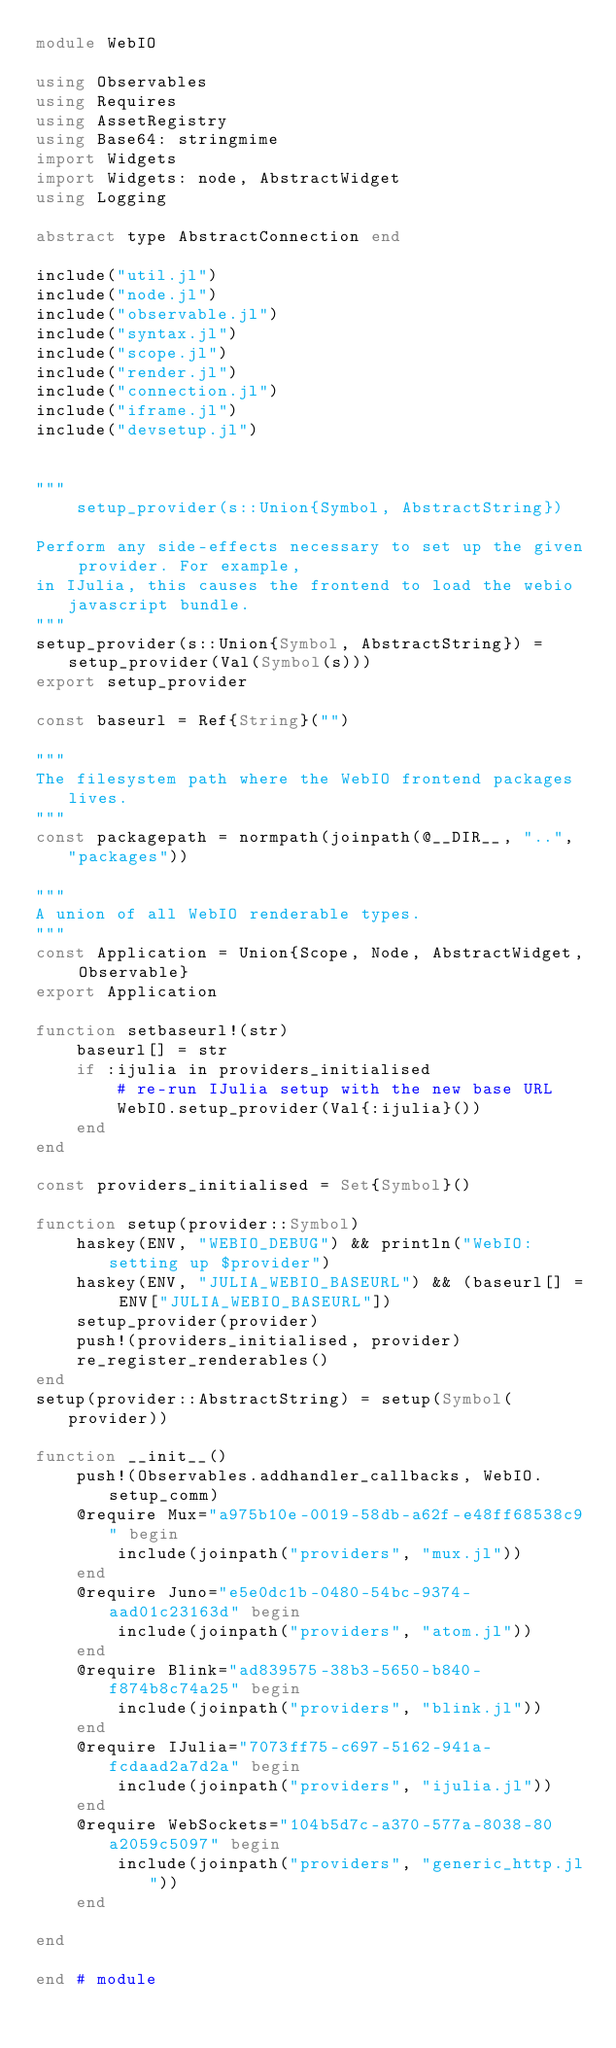Convert code to text. <code><loc_0><loc_0><loc_500><loc_500><_Julia_>module WebIO

using Observables
using Requires
using AssetRegistry
using Base64: stringmime
import Widgets
import Widgets: node, AbstractWidget
using Logging

abstract type AbstractConnection end

include("util.jl")
include("node.jl")
include("observable.jl")
include("syntax.jl")
include("scope.jl")
include("render.jl")
include("connection.jl")
include("iframe.jl")
include("devsetup.jl")


"""
    setup_provider(s::Union{Symbol, AbstractString})

Perform any side-effects necessary to set up the given provider. For example,
in IJulia, this causes the frontend to load the webio javascript bundle.
"""
setup_provider(s::Union{Symbol, AbstractString}) = setup_provider(Val(Symbol(s)))
export setup_provider

const baseurl = Ref{String}("")

"""
The filesystem path where the WebIO frontend packages lives.
"""
const packagepath = normpath(joinpath(@__DIR__, "..", "packages"))

"""
A union of all WebIO renderable types.
"""
const Application = Union{Scope, Node, AbstractWidget, Observable}
export Application

function setbaseurl!(str)
    baseurl[] = str
    if :ijulia in providers_initialised
        # re-run IJulia setup with the new base URL
        WebIO.setup_provider(Val{:ijulia}())
    end
end

const providers_initialised = Set{Symbol}()

function setup(provider::Symbol)
    haskey(ENV, "WEBIO_DEBUG") && println("WebIO: setting up $provider")
    haskey(ENV, "JULIA_WEBIO_BASEURL") && (baseurl[] = ENV["JULIA_WEBIO_BASEURL"])
    setup_provider(provider)
    push!(providers_initialised, provider)
    re_register_renderables()
end
setup(provider::AbstractString) = setup(Symbol(provider))

function __init__()
    push!(Observables.addhandler_callbacks, WebIO.setup_comm)
    @require Mux="a975b10e-0019-58db-a62f-e48ff68538c9" begin
        include(joinpath("providers", "mux.jl"))
    end
    @require Juno="e5e0dc1b-0480-54bc-9374-aad01c23163d" begin
        include(joinpath("providers", "atom.jl"))
    end
    @require Blink="ad839575-38b3-5650-b840-f874b8c74a25" begin
        include(joinpath("providers", "blink.jl"))
    end
    @require IJulia="7073ff75-c697-5162-941a-fcdaad2a7d2a" begin
        include(joinpath("providers", "ijulia.jl"))
    end
    @require WebSockets="104b5d7c-a370-577a-8038-80a2059c5097" begin
        include(joinpath("providers", "generic_http.jl"))
    end

end

end # module
</code> 